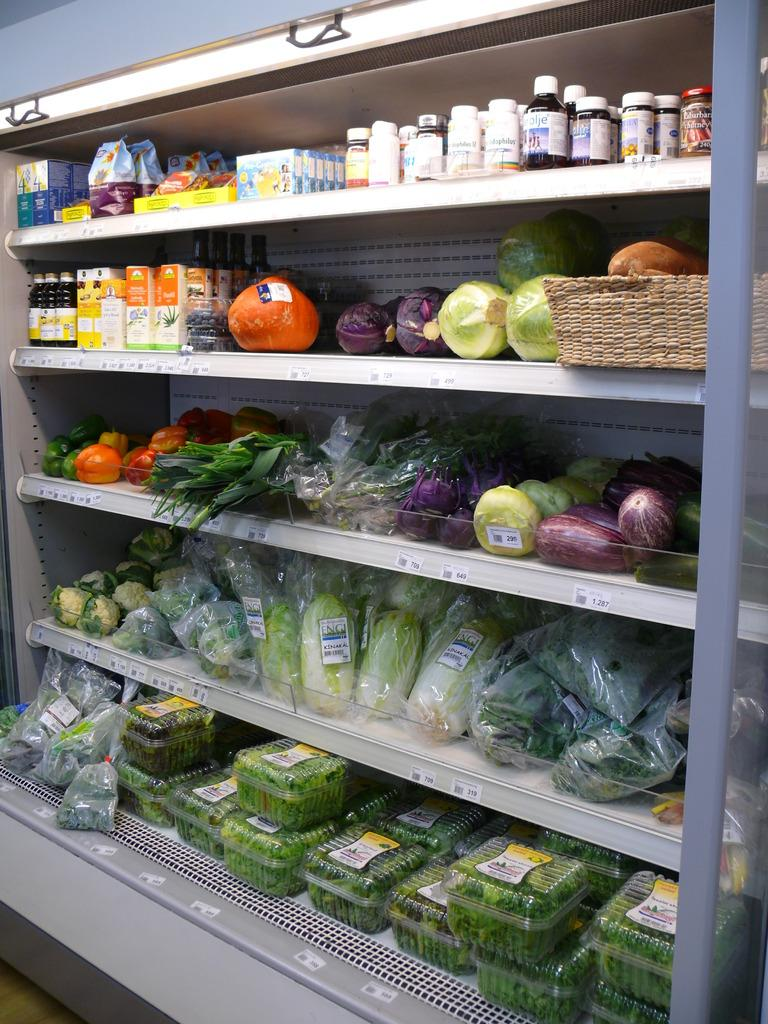What types of items can be seen in the image? There are food items, drinks, and vegetables in the image. How are these items arranged in the image? The food items, drinks, and vegetables are arranged in a rack. What type of hydrant can be seen in the image? There is no hydrant present in the image. What time is displayed on the clock in the image? There is no clock present in the image. 